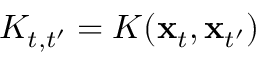<formula> <loc_0><loc_0><loc_500><loc_500>K _ { t , t ^ { \prime } } = K ( \mathbf x _ { t } , \mathbf x _ { t ^ { \prime } } )</formula> 